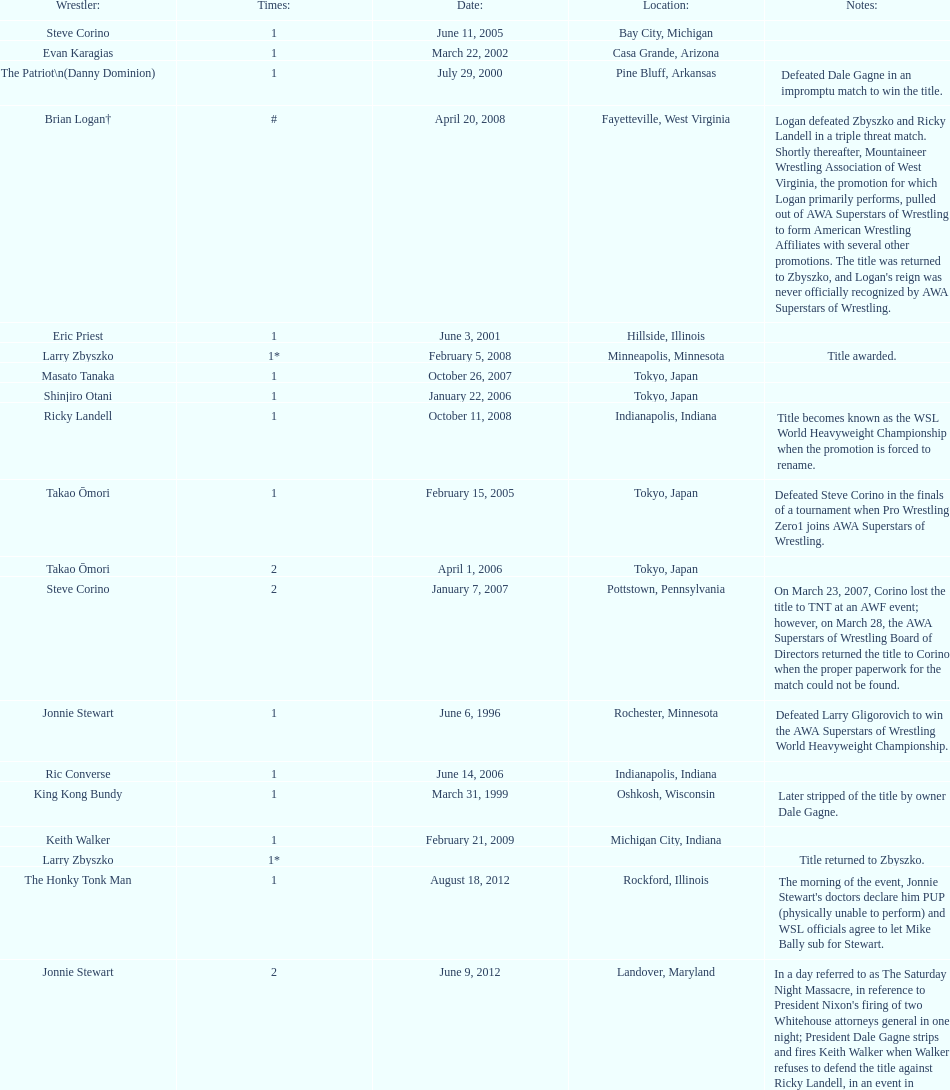I'm looking to parse the entire table for insights. Could you assist me with that? {'header': ['Wrestler:', 'Times:', 'Date:', 'Location:', 'Notes:'], 'rows': [['Steve Corino', '1', 'June 11, 2005', 'Bay City, Michigan', ''], ['Evan Karagias', '1', 'March 22, 2002', 'Casa Grande, Arizona', ''], ['The Patriot\\n(Danny Dominion)', '1', 'July 29, 2000', 'Pine Bluff, Arkansas', 'Defeated Dale Gagne in an impromptu match to win the title.'], ['Brian Logan†', '#', 'April 20, 2008', 'Fayetteville, West Virginia', "Logan defeated Zbyszko and Ricky Landell in a triple threat match. Shortly thereafter, Mountaineer Wrestling Association of West Virginia, the promotion for which Logan primarily performs, pulled out of AWA Superstars of Wrestling to form American Wrestling Affiliates with several other promotions. The title was returned to Zbyszko, and Logan's reign was never officially recognized by AWA Superstars of Wrestling."], ['Eric Priest', '1', 'June 3, 2001', 'Hillside, Illinois', ''], ['Larry Zbyszko', '1*', 'February 5, 2008', 'Minneapolis, Minnesota', 'Title awarded.'], ['Masato Tanaka', '1', 'October 26, 2007', 'Tokyo, Japan', ''], ['Shinjiro Otani', '1', 'January 22, 2006', 'Tokyo, Japan', ''], ['Ricky Landell', '1', 'October 11, 2008', 'Indianapolis, Indiana', 'Title becomes known as the WSL World Heavyweight Championship when the promotion is forced to rename.'], ['Takao Ōmori', '1', 'February 15, 2005', 'Tokyo, Japan', 'Defeated Steve Corino in the finals of a tournament when Pro Wrestling Zero1 joins AWA Superstars of Wrestling.'], ['Takao Ōmori', '2', 'April 1, 2006', 'Tokyo, Japan', ''], ['Steve Corino', '2', 'January 7, 2007', 'Pottstown, Pennsylvania', 'On March 23, 2007, Corino lost the title to TNT at an AWF event; however, on March 28, the AWA Superstars of Wrestling Board of Directors returned the title to Corino when the proper paperwork for the match could not be found.'], ['Jonnie Stewart', '1', 'June 6, 1996', 'Rochester, Minnesota', 'Defeated Larry Gligorovich to win the AWA Superstars of Wrestling World Heavyweight Championship.'], ['Ric Converse', '1', 'June 14, 2006', 'Indianapolis, Indiana', ''], ['King Kong Bundy', '1', 'March 31, 1999', 'Oshkosh, Wisconsin', 'Later stripped of the title by owner Dale Gagne.'], ['Keith Walker', '1', 'February 21, 2009', 'Michigan City, Indiana', ''], ['Larry Zbyszko', '1*', '', '', 'Title returned to Zbyszko.'], ['The Honky Tonk Man', '1', 'August 18, 2012', 'Rockford, Illinois', "The morning of the event, Jonnie Stewart's doctors declare him PUP (physically unable to perform) and WSL officials agree to let Mike Bally sub for Stewart."], ['Jonnie Stewart', '2', 'June 9, 2012', 'Landover, Maryland', "In a day referred to as The Saturday Night Massacre, in reference to President Nixon's firing of two Whitehouse attorneys general in one night; President Dale Gagne strips and fires Keith Walker when Walker refuses to defend the title against Ricky Landell, in an event in Landover, Maryland. When Landell is awarded the title, he refuses to accept and is too promptly fired by Gagne, who than awards the title to Jonnie Stewart."], ['Horshu', '1', 'October 12, 2002', 'Mercedes, Texas', 'Stripped of the title due to missing mandatory title defenses.'], ['Evan Karagias', '2', 'July 6, 2003', 'Lemoore, California', 'Defeated Eric Priest to win the vacated title. Karagias was fired in January 2005 by Dale Gagne for misconduct and refusal of defending the title as scheduled.'], ['Ricky Enrique', '1', 'July 29, 2000', 'Pine Bluff, Arkansas', ''], ['Takao Ōmori', '3', 'March 31, 2007', 'Yokohama, Japan', '']]} How many different men held the wsl title before horshu won his first wsl title? 6. 